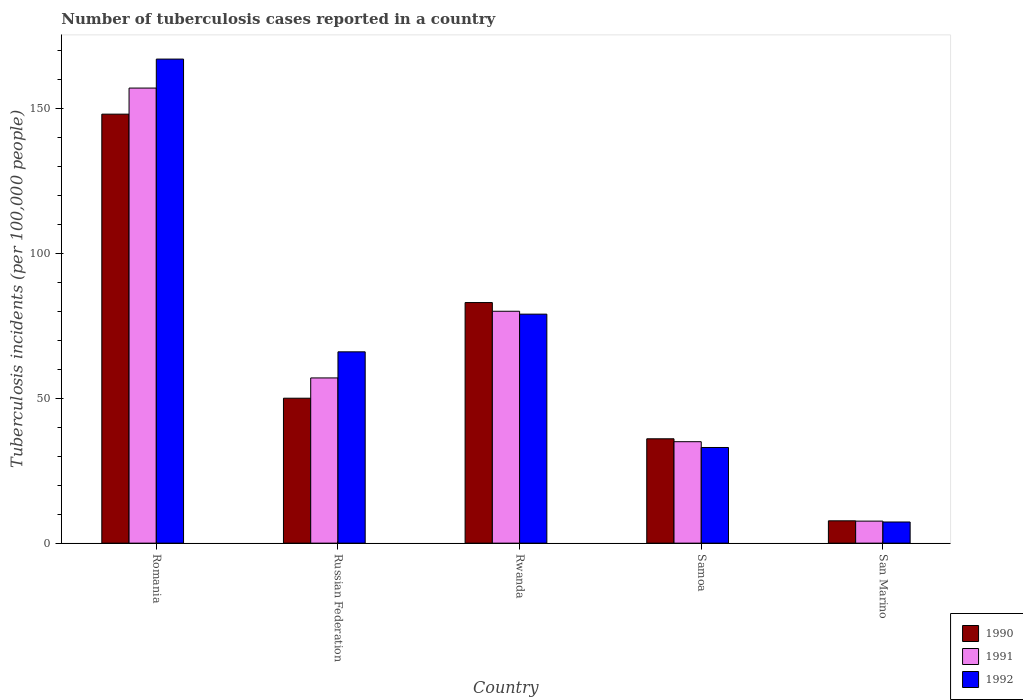Are the number of bars per tick equal to the number of legend labels?
Offer a terse response. Yes. Are the number of bars on each tick of the X-axis equal?
Give a very brief answer. Yes. What is the label of the 3rd group of bars from the left?
Your response must be concise. Rwanda. In how many cases, is the number of bars for a given country not equal to the number of legend labels?
Your response must be concise. 0. What is the number of tuberculosis cases reported in in 1990 in Russian Federation?
Offer a very short reply. 50. Across all countries, what is the maximum number of tuberculosis cases reported in in 1992?
Make the answer very short. 167. In which country was the number of tuberculosis cases reported in in 1990 maximum?
Offer a terse response. Romania. In which country was the number of tuberculosis cases reported in in 1991 minimum?
Provide a short and direct response. San Marino. What is the total number of tuberculosis cases reported in in 1992 in the graph?
Your answer should be very brief. 352.3. What is the difference between the number of tuberculosis cases reported in in 1990 in San Marino and the number of tuberculosis cases reported in in 1991 in Romania?
Keep it short and to the point. -149.3. What is the average number of tuberculosis cases reported in in 1991 per country?
Make the answer very short. 67.32. What is the ratio of the number of tuberculosis cases reported in in 1992 in Rwanda to that in Samoa?
Offer a terse response. 2.39. Is the number of tuberculosis cases reported in in 1991 in Russian Federation less than that in Rwanda?
Make the answer very short. Yes. What is the difference between the highest and the second highest number of tuberculosis cases reported in in 1992?
Provide a succinct answer. -13. What is the difference between the highest and the lowest number of tuberculosis cases reported in in 1991?
Provide a short and direct response. 149.4. Is the sum of the number of tuberculosis cases reported in in 1990 in Russian Federation and Samoa greater than the maximum number of tuberculosis cases reported in in 1992 across all countries?
Give a very brief answer. No. How many bars are there?
Offer a terse response. 15. How many countries are there in the graph?
Provide a short and direct response. 5. What is the difference between two consecutive major ticks on the Y-axis?
Provide a short and direct response. 50. Does the graph contain grids?
Offer a very short reply. No. Where does the legend appear in the graph?
Keep it short and to the point. Bottom right. How are the legend labels stacked?
Your answer should be compact. Vertical. What is the title of the graph?
Make the answer very short. Number of tuberculosis cases reported in a country. Does "1989" appear as one of the legend labels in the graph?
Your response must be concise. No. What is the label or title of the X-axis?
Ensure brevity in your answer.  Country. What is the label or title of the Y-axis?
Make the answer very short. Tuberculosis incidents (per 100,0 people). What is the Tuberculosis incidents (per 100,000 people) of 1990 in Romania?
Make the answer very short. 148. What is the Tuberculosis incidents (per 100,000 people) of 1991 in Romania?
Make the answer very short. 157. What is the Tuberculosis incidents (per 100,000 people) in 1992 in Romania?
Ensure brevity in your answer.  167. What is the Tuberculosis incidents (per 100,000 people) in 1990 in Russian Federation?
Give a very brief answer. 50. What is the Tuberculosis incidents (per 100,000 people) in 1990 in Rwanda?
Your answer should be compact. 83. What is the Tuberculosis incidents (per 100,000 people) of 1992 in Rwanda?
Keep it short and to the point. 79. What is the Tuberculosis incidents (per 100,000 people) in 1991 in Samoa?
Your answer should be very brief. 35. What is the Tuberculosis incidents (per 100,000 people) of 1992 in San Marino?
Your response must be concise. 7.3. Across all countries, what is the maximum Tuberculosis incidents (per 100,000 people) of 1990?
Your answer should be compact. 148. Across all countries, what is the maximum Tuberculosis incidents (per 100,000 people) of 1991?
Keep it short and to the point. 157. Across all countries, what is the maximum Tuberculosis incidents (per 100,000 people) in 1992?
Offer a terse response. 167. What is the total Tuberculosis incidents (per 100,000 people) of 1990 in the graph?
Keep it short and to the point. 324.7. What is the total Tuberculosis incidents (per 100,000 people) in 1991 in the graph?
Give a very brief answer. 336.6. What is the total Tuberculosis incidents (per 100,000 people) of 1992 in the graph?
Your answer should be very brief. 352.3. What is the difference between the Tuberculosis incidents (per 100,000 people) in 1990 in Romania and that in Russian Federation?
Offer a terse response. 98. What is the difference between the Tuberculosis incidents (per 100,000 people) in 1991 in Romania and that in Russian Federation?
Offer a terse response. 100. What is the difference between the Tuberculosis incidents (per 100,000 people) of 1992 in Romania and that in Russian Federation?
Provide a succinct answer. 101. What is the difference between the Tuberculosis incidents (per 100,000 people) in 1991 in Romania and that in Rwanda?
Offer a terse response. 77. What is the difference between the Tuberculosis incidents (per 100,000 people) in 1990 in Romania and that in Samoa?
Offer a very short reply. 112. What is the difference between the Tuberculosis incidents (per 100,000 people) in 1991 in Romania and that in Samoa?
Your answer should be very brief. 122. What is the difference between the Tuberculosis incidents (per 100,000 people) of 1992 in Romania and that in Samoa?
Provide a short and direct response. 134. What is the difference between the Tuberculosis incidents (per 100,000 people) in 1990 in Romania and that in San Marino?
Provide a succinct answer. 140.3. What is the difference between the Tuberculosis incidents (per 100,000 people) of 1991 in Romania and that in San Marino?
Your answer should be compact. 149.4. What is the difference between the Tuberculosis incidents (per 100,000 people) of 1992 in Romania and that in San Marino?
Keep it short and to the point. 159.7. What is the difference between the Tuberculosis incidents (per 100,000 people) of 1990 in Russian Federation and that in Rwanda?
Make the answer very short. -33. What is the difference between the Tuberculosis incidents (per 100,000 people) in 1991 in Russian Federation and that in Rwanda?
Offer a terse response. -23. What is the difference between the Tuberculosis incidents (per 100,000 people) in 1992 in Russian Federation and that in Rwanda?
Your answer should be very brief. -13. What is the difference between the Tuberculosis incidents (per 100,000 people) in 1991 in Russian Federation and that in Samoa?
Provide a succinct answer. 22. What is the difference between the Tuberculosis incidents (per 100,000 people) in 1992 in Russian Federation and that in Samoa?
Offer a very short reply. 33. What is the difference between the Tuberculosis incidents (per 100,000 people) of 1990 in Russian Federation and that in San Marino?
Your answer should be very brief. 42.3. What is the difference between the Tuberculosis incidents (per 100,000 people) of 1991 in Russian Federation and that in San Marino?
Keep it short and to the point. 49.4. What is the difference between the Tuberculosis incidents (per 100,000 people) of 1992 in Russian Federation and that in San Marino?
Ensure brevity in your answer.  58.7. What is the difference between the Tuberculosis incidents (per 100,000 people) in 1991 in Rwanda and that in Samoa?
Your answer should be compact. 45. What is the difference between the Tuberculosis incidents (per 100,000 people) of 1990 in Rwanda and that in San Marino?
Your answer should be very brief. 75.3. What is the difference between the Tuberculosis incidents (per 100,000 people) in 1991 in Rwanda and that in San Marino?
Give a very brief answer. 72.4. What is the difference between the Tuberculosis incidents (per 100,000 people) in 1992 in Rwanda and that in San Marino?
Your answer should be very brief. 71.7. What is the difference between the Tuberculosis incidents (per 100,000 people) in 1990 in Samoa and that in San Marino?
Make the answer very short. 28.3. What is the difference between the Tuberculosis incidents (per 100,000 people) in 1991 in Samoa and that in San Marino?
Make the answer very short. 27.4. What is the difference between the Tuberculosis incidents (per 100,000 people) in 1992 in Samoa and that in San Marino?
Ensure brevity in your answer.  25.7. What is the difference between the Tuberculosis incidents (per 100,000 people) in 1990 in Romania and the Tuberculosis incidents (per 100,000 people) in 1991 in Russian Federation?
Ensure brevity in your answer.  91. What is the difference between the Tuberculosis incidents (per 100,000 people) of 1991 in Romania and the Tuberculosis incidents (per 100,000 people) of 1992 in Russian Federation?
Keep it short and to the point. 91. What is the difference between the Tuberculosis incidents (per 100,000 people) in 1991 in Romania and the Tuberculosis incidents (per 100,000 people) in 1992 in Rwanda?
Provide a succinct answer. 78. What is the difference between the Tuberculosis incidents (per 100,000 people) of 1990 in Romania and the Tuberculosis incidents (per 100,000 people) of 1991 in Samoa?
Your response must be concise. 113. What is the difference between the Tuberculosis incidents (per 100,000 people) of 1990 in Romania and the Tuberculosis incidents (per 100,000 people) of 1992 in Samoa?
Offer a very short reply. 115. What is the difference between the Tuberculosis incidents (per 100,000 people) in 1991 in Romania and the Tuberculosis incidents (per 100,000 people) in 1992 in Samoa?
Make the answer very short. 124. What is the difference between the Tuberculosis incidents (per 100,000 people) in 1990 in Romania and the Tuberculosis incidents (per 100,000 people) in 1991 in San Marino?
Give a very brief answer. 140.4. What is the difference between the Tuberculosis incidents (per 100,000 people) in 1990 in Romania and the Tuberculosis incidents (per 100,000 people) in 1992 in San Marino?
Offer a terse response. 140.7. What is the difference between the Tuberculosis incidents (per 100,000 people) of 1991 in Romania and the Tuberculosis incidents (per 100,000 people) of 1992 in San Marino?
Make the answer very short. 149.7. What is the difference between the Tuberculosis incidents (per 100,000 people) of 1990 in Russian Federation and the Tuberculosis incidents (per 100,000 people) of 1992 in Rwanda?
Your answer should be very brief. -29. What is the difference between the Tuberculosis incidents (per 100,000 people) of 1991 in Russian Federation and the Tuberculosis incidents (per 100,000 people) of 1992 in Rwanda?
Keep it short and to the point. -22. What is the difference between the Tuberculosis incidents (per 100,000 people) of 1990 in Russian Federation and the Tuberculosis incidents (per 100,000 people) of 1991 in Samoa?
Your answer should be very brief. 15. What is the difference between the Tuberculosis incidents (per 100,000 people) in 1990 in Russian Federation and the Tuberculosis incidents (per 100,000 people) in 1991 in San Marino?
Your answer should be very brief. 42.4. What is the difference between the Tuberculosis incidents (per 100,000 people) in 1990 in Russian Federation and the Tuberculosis incidents (per 100,000 people) in 1992 in San Marino?
Give a very brief answer. 42.7. What is the difference between the Tuberculosis incidents (per 100,000 people) of 1991 in Russian Federation and the Tuberculosis incidents (per 100,000 people) of 1992 in San Marino?
Offer a terse response. 49.7. What is the difference between the Tuberculosis incidents (per 100,000 people) of 1990 in Rwanda and the Tuberculosis incidents (per 100,000 people) of 1991 in San Marino?
Make the answer very short. 75.4. What is the difference between the Tuberculosis incidents (per 100,000 people) of 1990 in Rwanda and the Tuberculosis incidents (per 100,000 people) of 1992 in San Marino?
Offer a very short reply. 75.7. What is the difference between the Tuberculosis incidents (per 100,000 people) of 1991 in Rwanda and the Tuberculosis incidents (per 100,000 people) of 1992 in San Marino?
Ensure brevity in your answer.  72.7. What is the difference between the Tuberculosis incidents (per 100,000 people) in 1990 in Samoa and the Tuberculosis incidents (per 100,000 people) in 1991 in San Marino?
Your response must be concise. 28.4. What is the difference between the Tuberculosis incidents (per 100,000 people) in 1990 in Samoa and the Tuberculosis incidents (per 100,000 people) in 1992 in San Marino?
Offer a very short reply. 28.7. What is the difference between the Tuberculosis incidents (per 100,000 people) in 1991 in Samoa and the Tuberculosis incidents (per 100,000 people) in 1992 in San Marino?
Your answer should be very brief. 27.7. What is the average Tuberculosis incidents (per 100,000 people) of 1990 per country?
Make the answer very short. 64.94. What is the average Tuberculosis incidents (per 100,000 people) in 1991 per country?
Keep it short and to the point. 67.32. What is the average Tuberculosis incidents (per 100,000 people) in 1992 per country?
Your answer should be compact. 70.46. What is the difference between the Tuberculosis incidents (per 100,000 people) of 1990 and Tuberculosis incidents (per 100,000 people) of 1991 in Romania?
Your answer should be compact. -9. What is the difference between the Tuberculosis incidents (per 100,000 people) in 1990 and Tuberculosis incidents (per 100,000 people) in 1992 in Romania?
Provide a succinct answer. -19. What is the difference between the Tuberculosis incidents (per 100,000 people) in 1991 and Tuberculosis incidents (per 100,000 people) in 1992 in Romania?
Ensure brevity in your answer.  -10. What is the difference between the Tuberculosis incidents (per 100,000 people) of 1990 and Tuberculosis incidents (per 100,000 people) of 1991 in Russian Federation?
Provide a short and direct response. -7. What is the difference between the Tuberculosis incidents (per 100,000 people) of 1990 and Tuberculosis incidents (per 100,000 people) of 1992 in Rwanda?
Provide a succinct answer. 4. What is the difference between the Tuberculosis incidents (per 100,000 people) of 1990 and Tuberculosis incidents (per 100,000 people) of 1992 in Samoa?
Your answer should be compact. 3. What is the difference between the Tuberculosis incidents (per 100,000 people) of 1990 and Tuberculosis incidents (per 100,000 people) of 1991 in San Marino?
Offer a very short reply. 0.1. What is the difference between the Tuberculosis incidents (per 100,000 people) of 1991 and Tuberculosis incidents (per 100,000 people) of 1992 in San Marino?
Offer a terse response. 0.3. What is the ratio of the Tuberculosis incidents (per 100,000 people) of 1990 in Romania to that in Russian Federation?
Keep it short and to the point. 2.96. What is the ratio of the Tuberculosis incidents (per 100,000 people) of 1991 in Romania to that in Russian Federation?
Give a very brief answer. 2.75. What is the ratio of the Tuberculosis incidents (per 100,000 people) of 1992 in Romania to that in Russian Federation?
Give a very brief answer. 2.53. What is the ratio of the Tuberculosis incidents (per 100,000 people) of 1990 in Romania to that in Rwanda?
Make the answer very short. 1.78. What is the ratio of the Tuberculosis incidents (per 100,000 people) of 1991 in Romania to that in Rwanda?
Offer a terse response. 1.96. What is the ratio of the Tuberculosis incidents (per 100,000 people) of 1992 in Romania to that in Rwanda?
Your answer should be compact. 2.11. What is the ratio of the Tuberculosis incidents (per 100,000 people) in 1990 in Romania to that in Samoa?
Your answer should be very brief. 4.11. What is the ratio of the Tuberculosis incidents (per 100,000 people) of 1991 in Romania to that in Samoa?
Your answer should be compact. 4.49. What is the ratio of the Tuberculosis incidents (per 100,000 people) of 1992 in Romania to that in Samoa?
Your response must be concise. 5.06. What is the ratio of the Tuberculosis incidents (per 100,000 people) in 1990 in Romania to that in San Marino?
Provide a succinct answer. 19.22. What is the ratio of the Tuberculosis incidents (per 100,000 people) of 1991 in Romania to that in San Marino?
Offer a terse response. 20.66. What is the ratio of the Tuberculosis incidents (per 100,000 people) in 1992 in Romania to that in San Marino?
Give a very brief answer. 22.88. What is the ratio of the Tuberculosis incidents (per 100,000 people) in 1990 in Russian Federation to that in Rwanda?
Give a very brief answer. 0.6. What is the ratio of the Tuberculosis incidents (per 100,000 people) in 1991 in Russian Federation to that in Rwanda?
Make the answer very short. 0.71. What is the ratio of the Tuberculosis incidents (per 100,000 people) in 1992 in Russian Federation to that in Rwanda?
Your answer should be very brief. 0.84. What is the ratio of the Tuberculosis incidents (per 100,000 people) of 1990 in Russian Federation to that in Samoa?
Offer a very short reply. 1.39. What is the ratio of the Tuberculosis incidents (per 100,000 people) in 1991 in Russian Federation to that in Samoa?
Your answer should be very brief. 1.63. What is the ratio of the Tuberculosis incidents (per 100,000 people) of 1990 in Russian Federation to that in San Marino?
Offer a terse response. 6.49. What is the ratio of the Tuberculosis incidents (per 100,000 people) in 1991 in Russian Federation to that in San Marino?
Make the answer very short. 7.5. What is the ratio of the Tuberculosis incidents (per 100,000 people) in 1992 in Russian Federation to that in San Marino?
Provide a short and direct response. 9.04. What is the ratio of the Tuberculosis incidents (per 100,000 people) in 1990 in Rwanda to that in Samoa?
Provide a short and direct response. 2.31. What is the ratio of the Tuberculosis incidents (per 100,000 people) in 1991 in Rwanda to that in Samoa?
Offer a very short reply. 2.29. What is the ratio of the Tuberculosis incidents (per 100,000 people) in 1992 in Rwanda to that in Samoa?
Your answer should be compact. 2.39. What is the ratio of the Tuberculosis incidents (per 100,000 people) in 1990 in Rwanda to that in San Marino?
Ensure brevity in your answer.  10.78. What is the ratio of the Tuberculosis incidents (per 100,000 people) in 1991 in Rwanda to that in San Marino?
Keep it short and to the point. 10.53. What is the ratio of the Tuberculosis incidents (per 100,000 people) of 1992 in Rwanda to that in San Marino?
Provide a succinct answer. 10.82. What is the ratio of the Tuberculosis incidents (per 100,000 people) in 1990 in Samoa to that in San Marino?
Offer a terse response. 4.68. What is the ratio of the Tuberculosis incidents (per 100,000 people) of 1991 in Samoa to that in San Marino?
Offer a very short reply. 4.61. What is the ratio of the Tuberculosis incidents (per 100,000 people) of 1992 in Samoa to that in San Marino?
Make the answer very short. 4.52. What is the difference between the highest and the second highest Tuberculosis incidents (per 100,000 people) in 1990?
Your answer should be very brief. 65. What is the difference between the highest and the second highest Tuberculosis incidents (per 100,000 people) in 1991?
Your response must be concise. 77. What is the difference between the highest and the lowest Tuberculosis incidents (per 100,000 people) in 1990?
Your response must be concise. 140.3. What is the difference between the highest and the lowest Tuberculosis incidents (per 100,000 people) in 1991?
Provide a short and direct response. 149.4. What is the difference between the highest and the lowest Tuberculosis incidents (per 100,000 people) in 1992?
Make the answer very short. 159.7. 